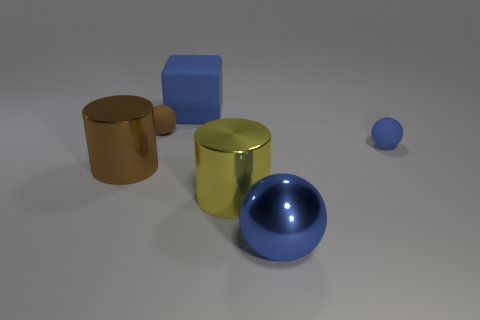There is a rubber object that is the same color as the block; what is its size?
Your answer should be compact. Small. What is the shape of the small matte object that is the same color as the block?
Offer a terse response. Sphere. Are there any blue matte blocks of the same size as the metallic ball?
Make the answer very short. Yes. Are there more big metal things that are behind the big rubber block than tiny cubes?
Keep it short and to the point. No. What number of large things are cyan metallic things or brown matte things?
Your answer should be compact. 0. How many large red matte things are the same shape as the large yellow shiny object?
Keep it short and to the point. 0. There is a big thing that is behind the small sphere that is right of the blue shiny thing; what is its material?
Offer a terse response. Rubber. What is the size of the blue thing that is to the right of the large blue metallic ball?
Ensure brevity in your answer.  Small. What number of red objects are matte objects or small objects?
Provide a short and direct response. 0. Is there anything else that is the same material as the large blue cube?
Provide a short and direct response. Yes. 